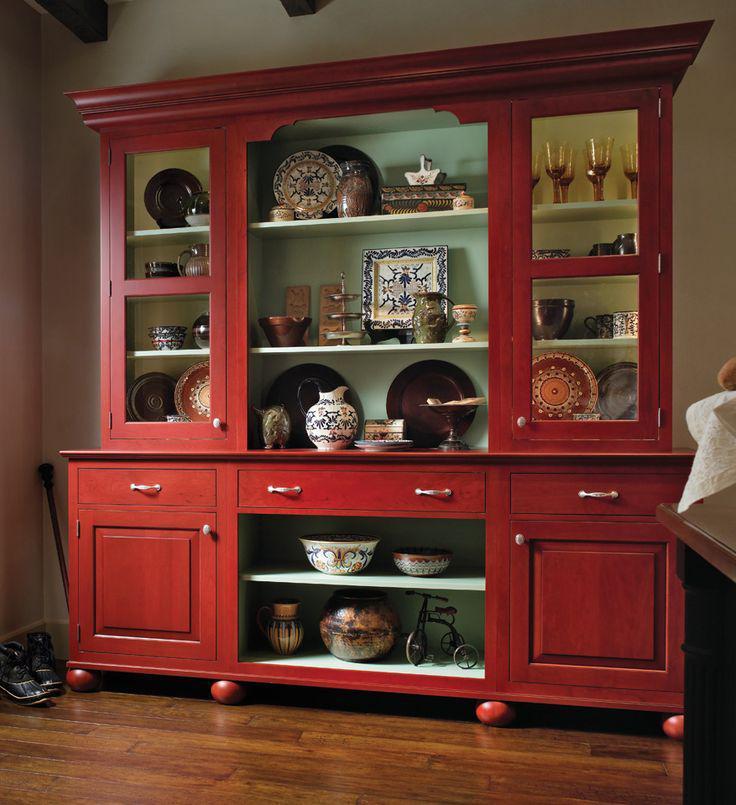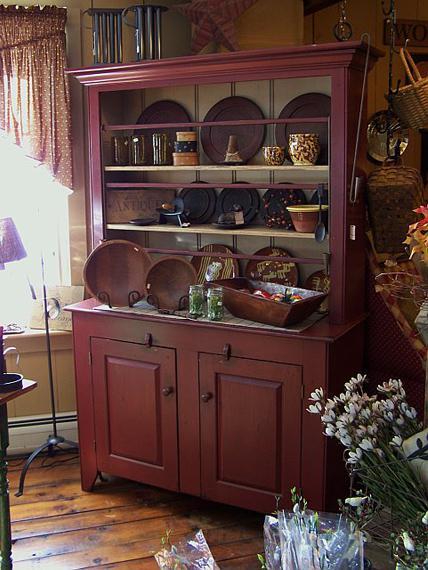The first image is the image on the left, the second image is the image on the right. Evaluate the accuracy of this statement regarding the images: "There is at least one deep red cabinet with legs.". Is it true? Answer yes or no. Yes. 